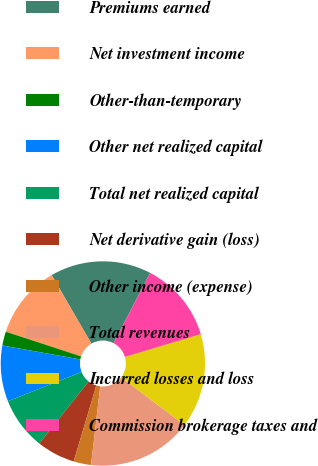Convert chart to OTSL. <chart><loc_0><loc_0><loc_500><loc_500><pie_chart><fcel>Premiums earned<fcel>Net investment income<fcel>Other-than-temporary<fcel>Other net realized capital<fcel>Total net realized capital<fcel>Net derivative gain (loss)<fcel>Other income (expense)<fcel>Total revenues<fcel>Incurred losses and loss<fcel>Commission brokerage taxes and<nl><fcel>16.02%<fcel>11.6%<fcel>2.21%<fcel>8.84%<fcel>8.29%<fcel>6.08%<fcel>2.76%<fcel>16.57%<fcel>14.92%<fcel>12.71%<nl></chart> 